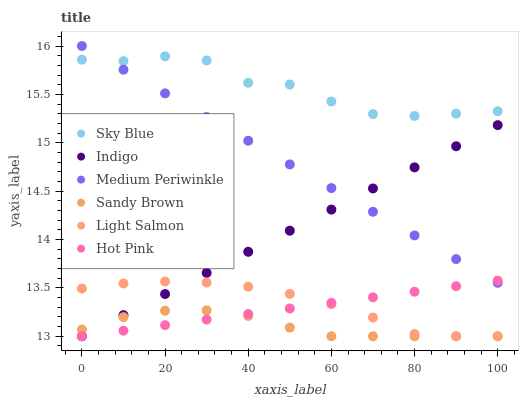Does Sandy Brown have the minimum area under the curve?
Answer yes or no. Yes. Does Sky Blue have the maximum area under the curve?
Answer yes or no. Yes. Does Indigo have the minimum area under the curve?
Answer yes or no. No. Does Indigo have the maximum area under the curve?
Answer yes or no. No. Is Indigo the smoothest?
Answer yes or no. Yes. Is Sky Blue the roughest?
Answer yes or no. Yes. Is Medium Periwinkle the smoothest?
Answer yes or no. No. Is Medium Periwinkle the roughest?
Answer yes or no. No. Does Light Salmon have the lowest value?
Answer yes or no. Yes. Does Medium Periwinkle have the lowest value?
Answer yes or no. No. Does Medium Periwinkle have the highest value?
Answer yes or no. Yes. Does Indigo have the highest value?
Answer yes or no. No. Is Sandy Brown less than Sky Blue?
Answer yes or no. Yes. Is Medium Periwinkle greater than Light Salmon?
Answer yes or no. Yes. Does Hot Pink intersect Indigo?
Answer yes or no. Yes. Is Hot Pink less than Indigo?
Answer yes or no. No. Is Hot Pink greater than Indigo?
Answer yes or no. No. Does Sandy Brown intersect Sky Blue?
Answer yes or no. No. 